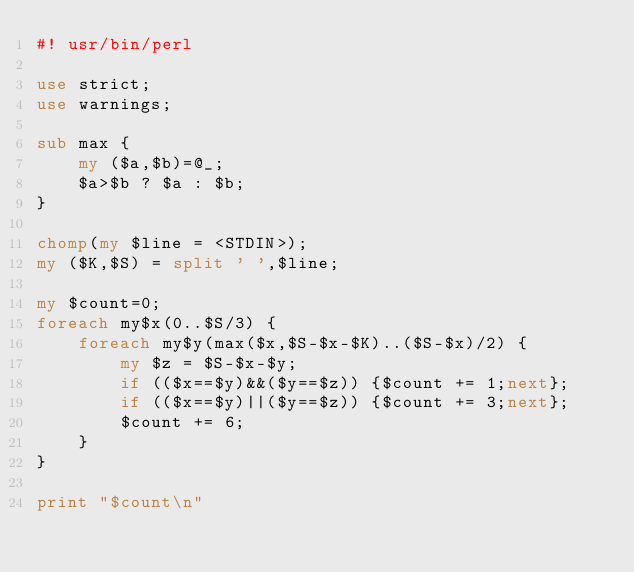<code> <loc_0><loc_0><loc_500><loc_500><_Perl_>#! usr/bin/perl

use strict;
use warnings;

sub max {
    my ($a,$b)=@_;
    $a>$b ? $a : $b;    
}

chomp(my $line = <STDIN>);
my ($K,$S) = split ' ',$line;

my $count=0;
foreach my$x(0..$S/3) {
    foreach my$y(max($x,$S-$x-$K)..($S-$x)/2) {
        my $z = $S-$x-$y;
        if (($x==$y)&&($y==$z)) {$count += 1;next};
        if (($x==$y)||($y==$z)) {$count += 3;next};
        $count += 6;
    }
}

print "$count\n"</code> 